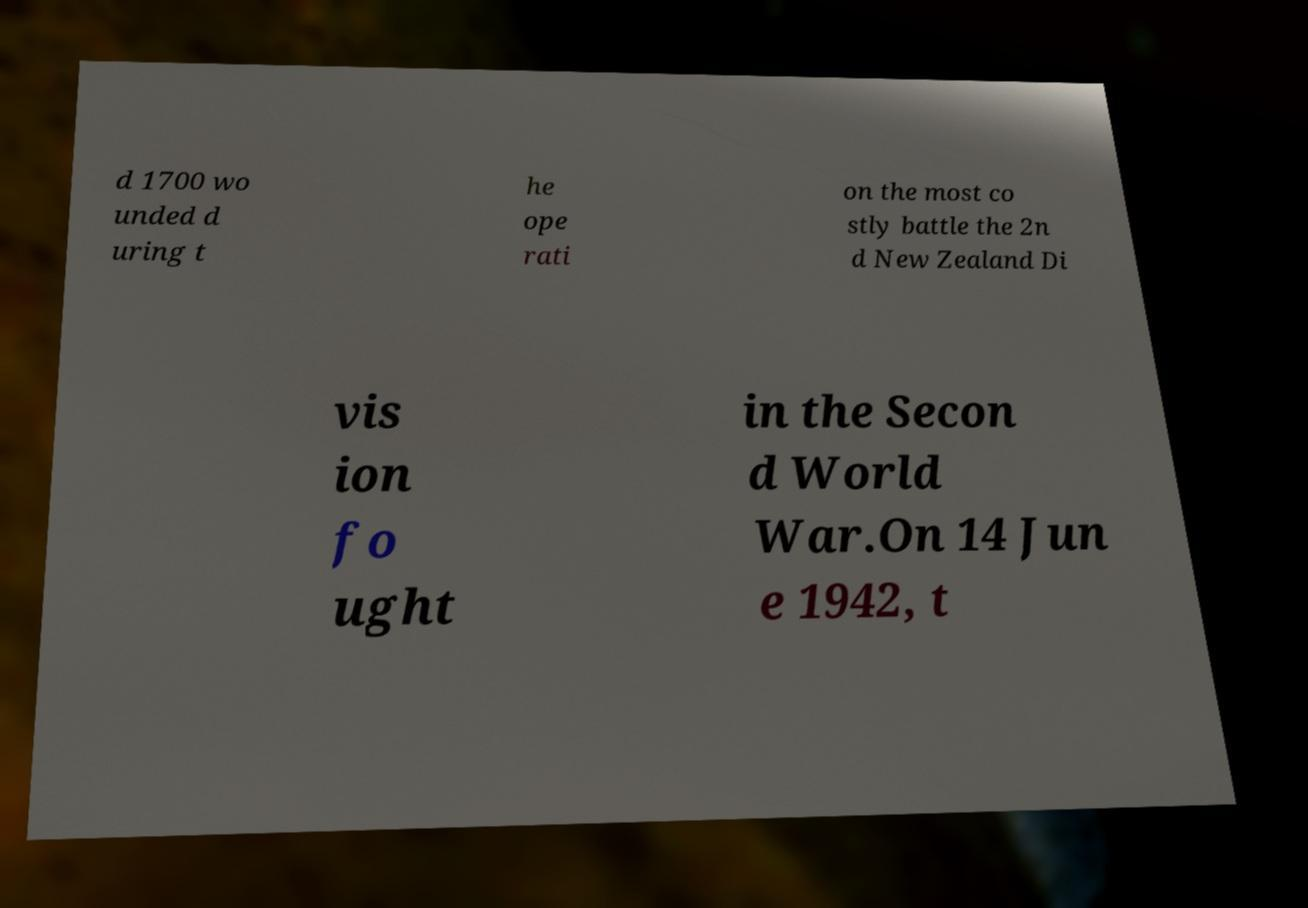Please identify and transcribe the text found in this image. d 1700 wo unded d uring t he ope rati on the most co stly battle the 2n d New Zealand Di vis ion fo ught in the Secon d World War.On 14 Jun e 1942, t 